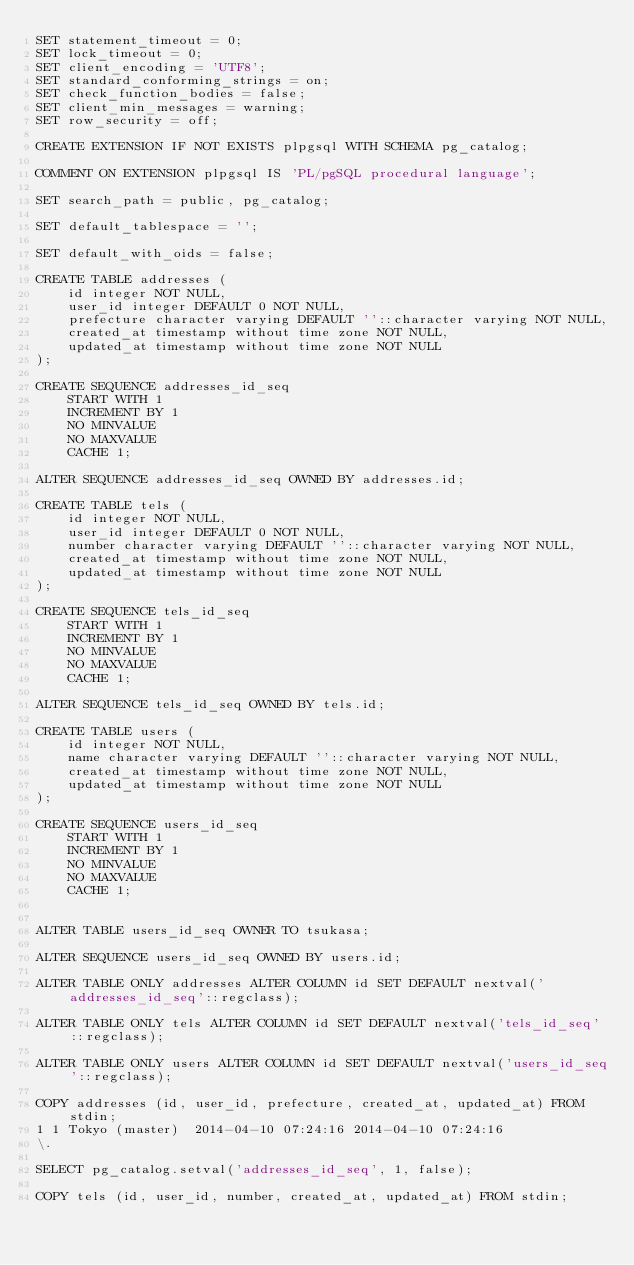<code> <loc_0><loc_0><loc_500><loc_500><_SQL_>SET statement_timeout = 0;
SET lock_timeout = 0;
SET client_encoding = 'UTF8';
SET standard_conforming_strings = on;
SET check_function_bodies = false;
SET client_min_messages = warning;
SET row_security = off;

CREATE EXTENSION IF NOT EXISTS plpgsql WITH SCHEMA pg_catalog;

COMMENT ON EXTENSION plpgsql IS 'PL/pgSQL procedural language';

SET search_path = public, pg_catalog;

SET default_tablespace = '';

SET default_with_oids = false;

CREATE TABLE addresses (
    id integer NOT NULL,
    user_id integer DEFAULT 0 NOT NULL,
    prefecture character varying DEFAULT ''::character varying NOT NULL,
    created_at timestamp without time zone NOT NULL,
    updated_at timestamp without time zone NOT NULL
);

CREATE SEQUENCE addresses_id_seq
    START WITH 1
    INCREMENT BY 1
    NO MINVALUE
    NO MAXVALUE
    CACHE 1;

ALTER SEQUENCE addresses_id_seq OWNED BY addresses.id;

CREATE TABLE tels (
    id integer NOT NULL,
    user_id integer DEFAULT 0 NOT NULL,
    number character varying DEFAULT ''::character varying NOT NULL,
    created_at timestamp without time zone NOT NULL,
    updated_at timestamp without time zone NOT NULL
);

CREATE SEQUENCE tels_id_seq
    START WITH 1
    INCREMENT BY 1
    NO MINVALUE
    NO MAXVALUE
    CACHE 1;

ALTER SEQUENCE tels_id_seq OWNED BY tels.id;

CREATE TABLE users (
    id integer NOT NULL,
    name character varying DEFAULT ''::character varying NOT NULL,
    created_at timestamp without time zone NOT NULL,
    updated_at timestamp without time zone NOT NULL
);

CREATE SEQUENCE users_id_seq
    START WITH 1
    INCREMENT BY 1
    NO MINVALUE
    NO MAXVALUE
    CACHE 1;


ALTER TABLE users_id_seq OWNER TO tsukasa;

ALTER SEQUENCE users_id_seq OWNED BY users.id;

ALTER TABLE ONLY addresses ALTER COLUMN id SET DEFAULT nextval('addresses_id_seq'::regclass);

ALTER TABLE ONLY tels ALTER COLUMN id SET DEFAULT nextval('tels_id_seq'::regclass);

ALTER TABLE ONLY users ALTER COLUMN id SET DEFAULT nextval('users_id_seq'::regclass);

COPY addresses (id, user_id, prefecture, created_at, updated_at) FROM stdin;
1	1	Tokyo (master)	2014-04-10 07:24:16	2014-04-10 07:24:16
\.

SELECT pg_catalog.setval('addresses_id_seq', 1, false);

COPY tels (id, user_id, number, created_at, updated_at) FROM stdin;</code> 